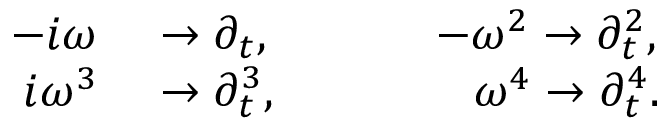Convert formula to latex. <formula><loc_0><loc_0><loc_500><loc_500>\begin{array} { r l } { - i \omega } & \rightarrow \partial _ { t } , - \omega ^ { 2 } \rightarrow \partial _ { t } ^ { 2 } , } \\ { i \omega ^ { 3 } } & \rightarrow \partial _ { t } ^ { 3 } , \omega ^ { 4 } \rightarrow \partial _ { t } ^ { 4 } . } \end{array}</formula> 